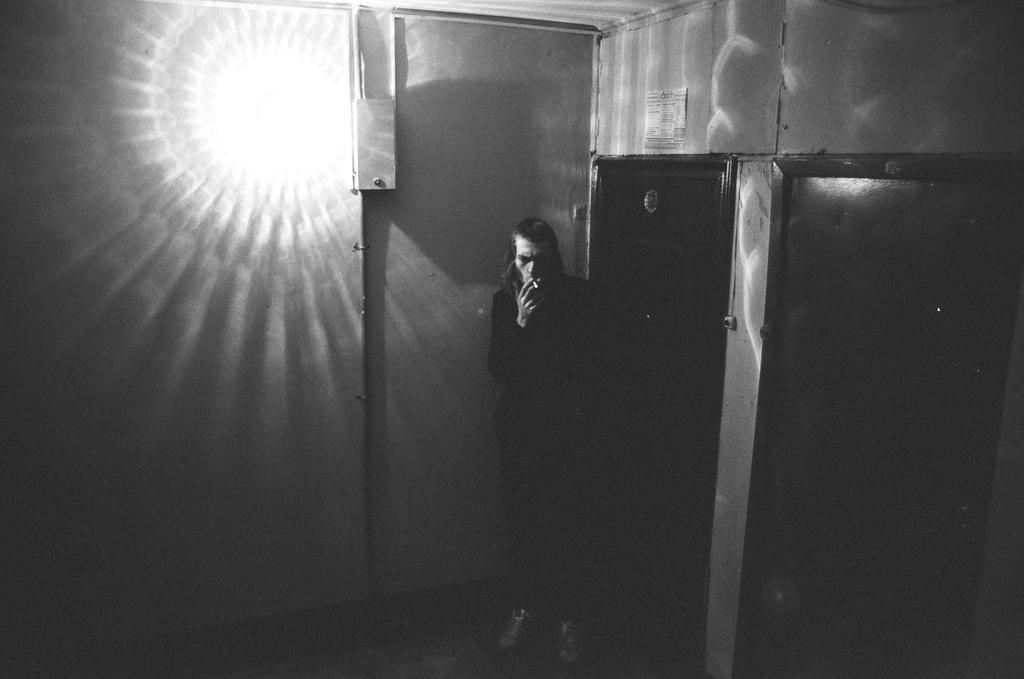What is the person in the image doing? The person is standing beside the door. What is behind the person in the image? There is a wall behind the person. What is on the wall behind the person? There is a poster on the wall. What can be seen on the wall in the image? There is light on the wall. What type of curve can be seen in the person's thought process in the image? There is no indication of the person's thought process in the image, and therefore no curve can be observed. 